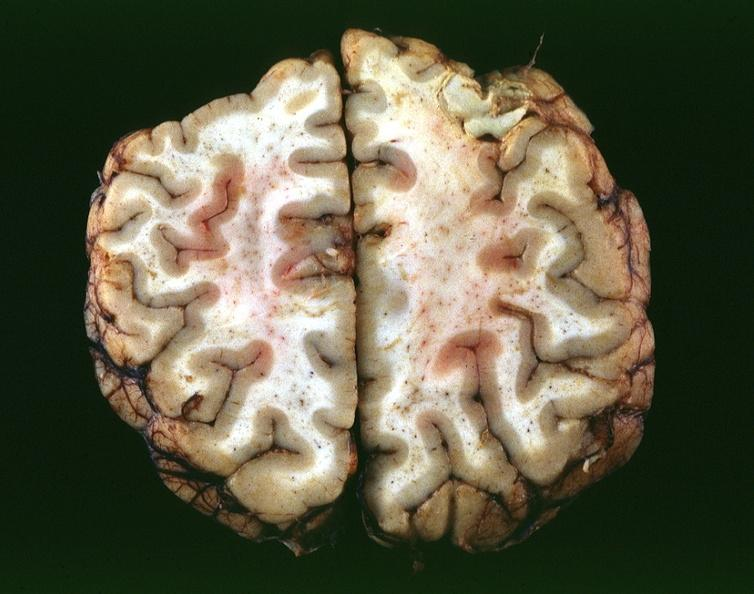does this close-up of cut surface infiltrates show toxoplasmosis, brain?
Answer the question using a single word or phrase. No 